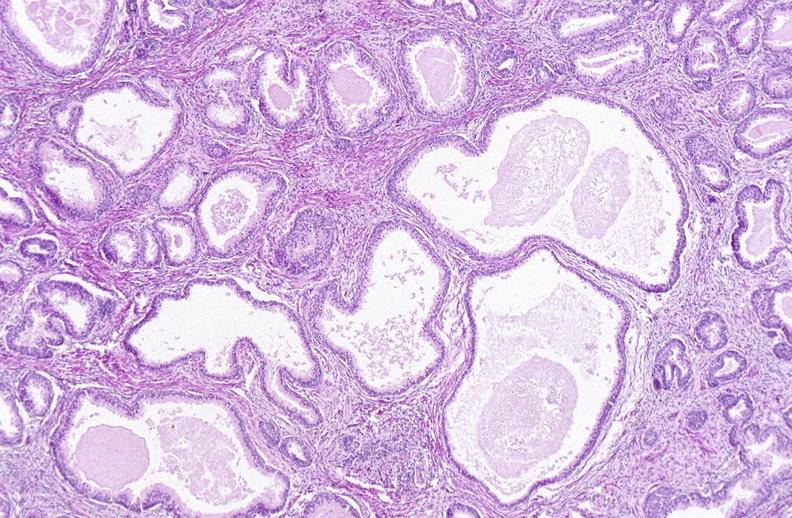does this image show prostate, cystic glands?
Answer the question using a single word or phrase. Yes 